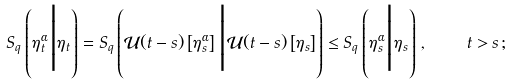<formula> <loc_0><loc_0><loc_500><loc_500>S _ { q } \left ( \eta _ { t } ^ { \alpha } \Big | \eta _ { t } \right ) = S _ { q } \left ( \mathcal { U } ( t - s ) \left [ \eta _ { s } ^ { \alpha } \right ] \Big | \mathcal { U } ( t - s ) \left [ \eta _ { s } \right ] \right ) \leq S _ { q } \left ( \eta _ { s } ^ { \alpha } \Big | \eta _ { s } \right ) \, , \quad t > s \, ;</formula> 